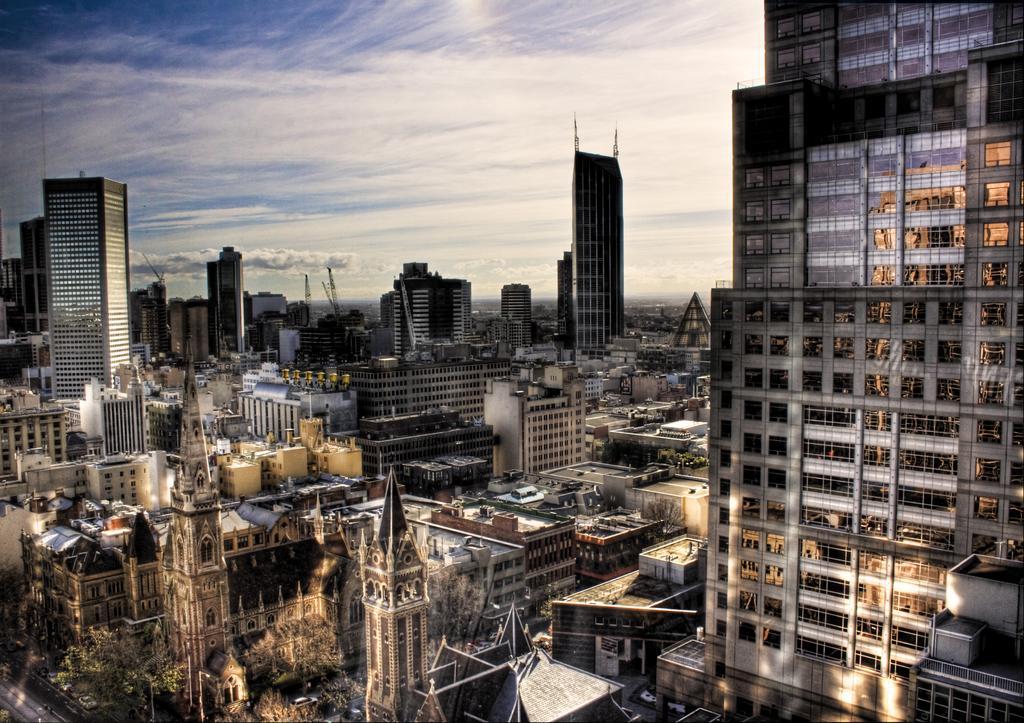How would you summarize this image in a sentence or two? This is the top view of a city, in this image there are vehicles on the roads, lamp posts, trees, and buildings, at the top of the image there are clouds in the sky. 